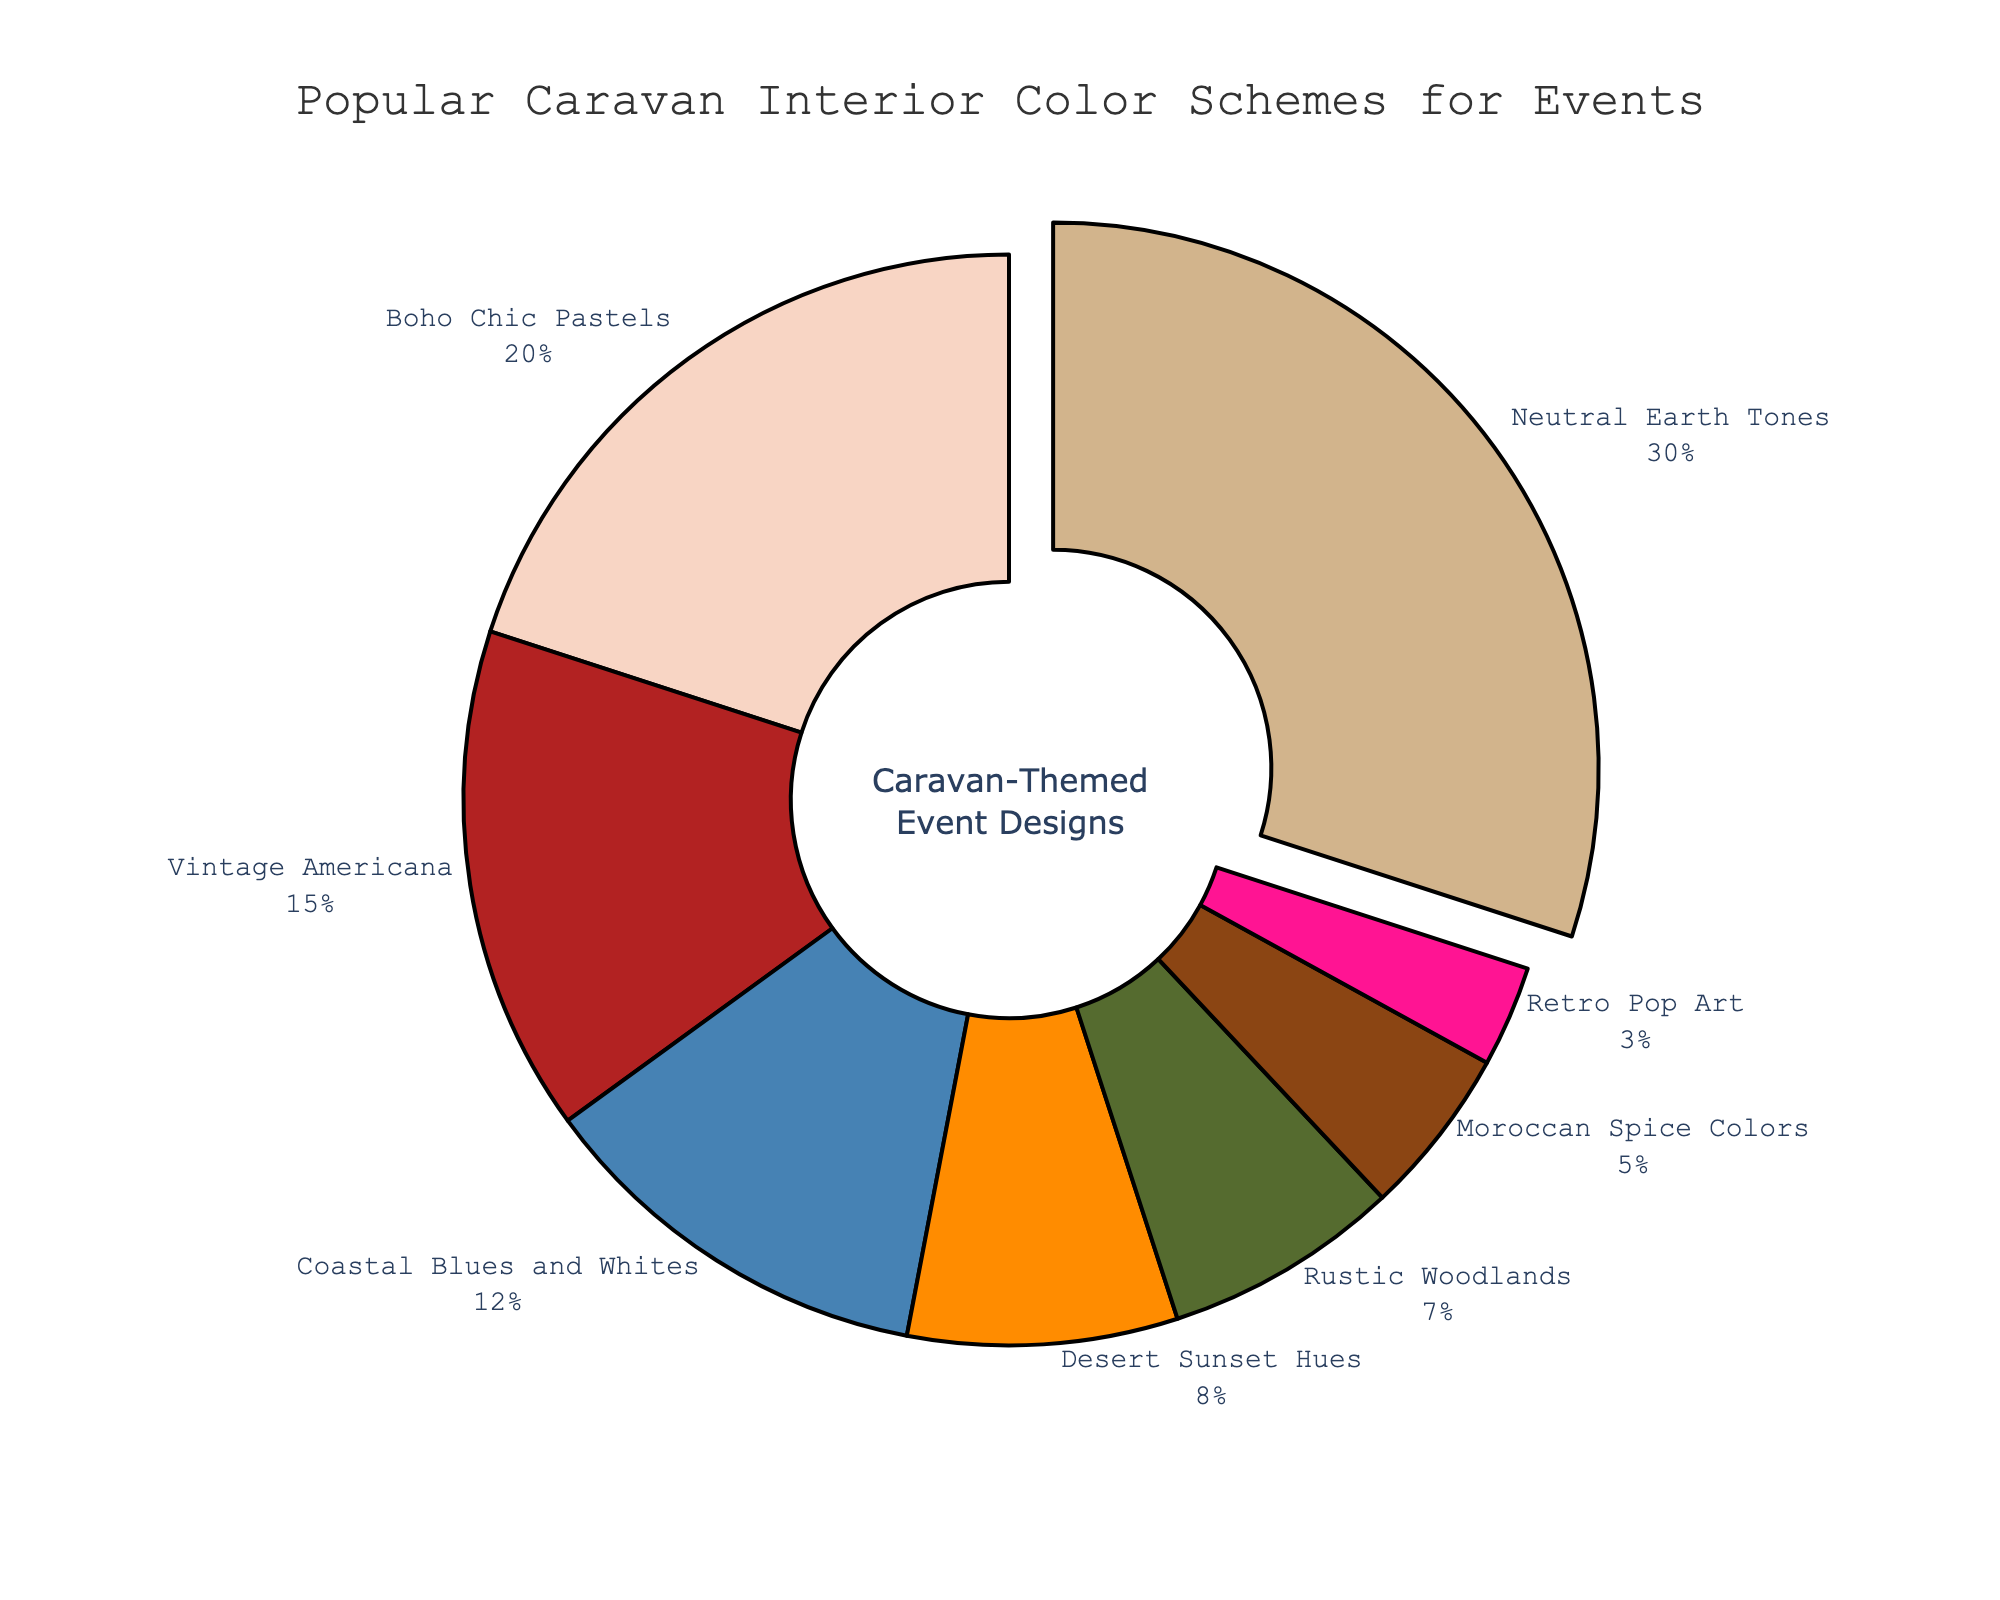Which color scheme is the most popular? The slice with the largest percentage represents the most popular color scheme, which is labeled "Neutral Earth Tones" with 30%.
Answer: Neutral Earth Tones Which color scheme is the least popular? The slice with the smallest percentage represents the least popular color scheme, which is labeled "Retro Pop Art" with 3%.
Answer: Retro Pop Art What percentage of people prefer Boho Chic Pastels? Refer to the slice labeled "Boho Chic Pastels." The label indicates that 20% prefer this color scheme.
Answer: 20% How much more popular are Coastal Blues and Whites compared to Rustic Woodlands? The percentage for Coastal Blues and Whites is 12%, and for Rustic Woodlands, it is 7%. The difference is 12% - 7% = 5%.
Answer: 5% Sum the percentages of the least three popular color schemes. The least three popular color schemes are "Retro Pop Art" (3%), "Moroccan Spice Colors" (5%), and "Rustic Woodlands" (7%). Summing these up gives 3% + 5% + 7% = 15%.
Answer: 15% Compare the popularity between Desert Sunset Hues and either Boho Chic Pastels or Vintage Americana. The percentage for Desert Sunset Hues is 8%. When compared to Boho Chic Pastels (20%) and Vintage Americana (15%), Desert Sunset Hues is less popular than both.
Answer: Desert Sunset Hues is less popular What are the two most popular color schemes? The largest slices represent the two most popular color schemes: "Neutral Earth Tones" (30%) and "Boho Chic Pastels" (20%).
Answer: Neutral Earth Tones and Boho Chic Pastels What is the combined percentage of Neutral Earth Tones and Coastal Blues and Whites? The percentage for Neutral Earth Tones is 30%, and for Coastal Blues and Whites, it is 12%. The combined percentage is 30% + 12% = 42%.
Answer: 42% Which color schemes occupy more than 15% of the total proportions? The slices for color schemes with more than 15% are labeled "Neutral Earth Tones" (30%) and "Boho Chic Pastels" (20%).
Answer: Neutral Earth Tones and Boho Chic Pastels 